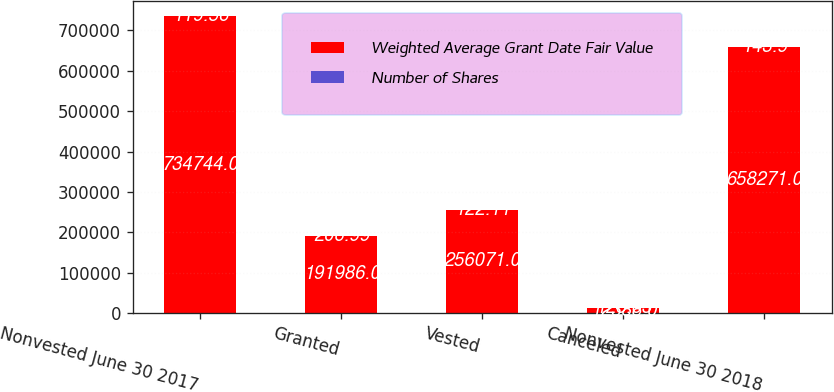Convert chart to OTSL. <chart><loc_0><loc_0><loc_500><loc_500><stacked_bar_chart><ecel><fcel>Nonvested June 30 2017<fcel>Granted<fcel>Vested<fcel>Canceled<fcel>Nonvested June 30 2018<nl><fcel>Weighted Average Grant Date Fair Value<fcel>734744<fcel>191986<fcel>256071<fcel>12388<fcel>658271<nl><fcel>Number of Shares<fcel>119.56<fcel>206.99<fcel>122.11<fcel>128.63<fcel>143.9<nl></chart> 